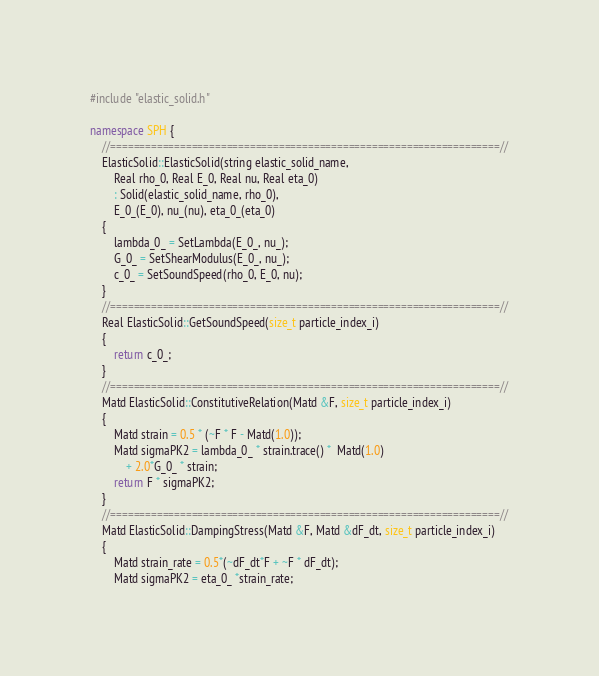Convert code to text. <code><loc_0><loc_0><loc_500><loc_500><_C++_>#include "elastic_solid.h"

namespace SPH {
	//===================================================================//
	ElasticSolid::ElasticSolid(string elastic_solid_name,
		Real rho_0, Real E_0, Real nu, Real eta_0)
		: Solid(elastic_solid_name, rho_0), 
		E_0_(E_0), nu_(nu), eta_0_(eta_0)
	{	
		lambda_0_ = SetLambda(E_0_, nu_);
		G_0_ = SetShearModulus(E_0_, nu_);
		c_0_ = SetSoundSpeed(rho_0, E_0, nu);
	}
	//===================================================================//
	Real ElasticSolid::GetSoundSpeed(size_t particle_index_i)
	{
		return c_0_;
	}
	//===================================================================//
	Matd ElasticSolid::ConstitutiveRelation(Matd &F, size_t particle_index_i)
	{
		Matd strain = 0.5 * (~F * F - Matd(1.0));
		Matd sigmaPK2 = lambda_0_ * strain.trace() *  Matd(1.0)
			+ 2.0*G_0_ * strain;
		return F * sigmaPK2;
	}
	//===================================================================//
	Matd ElasticSolid::DampingStress(Matd &F, Matd &dF_dt, size_t particle_index_i)
	{
		Matd strain_rate = 0.5*(~dF_dt*F + ~F * dF_dt);
		Matd sigmaPK2 = eta_0_ *strain_rate;</code> 